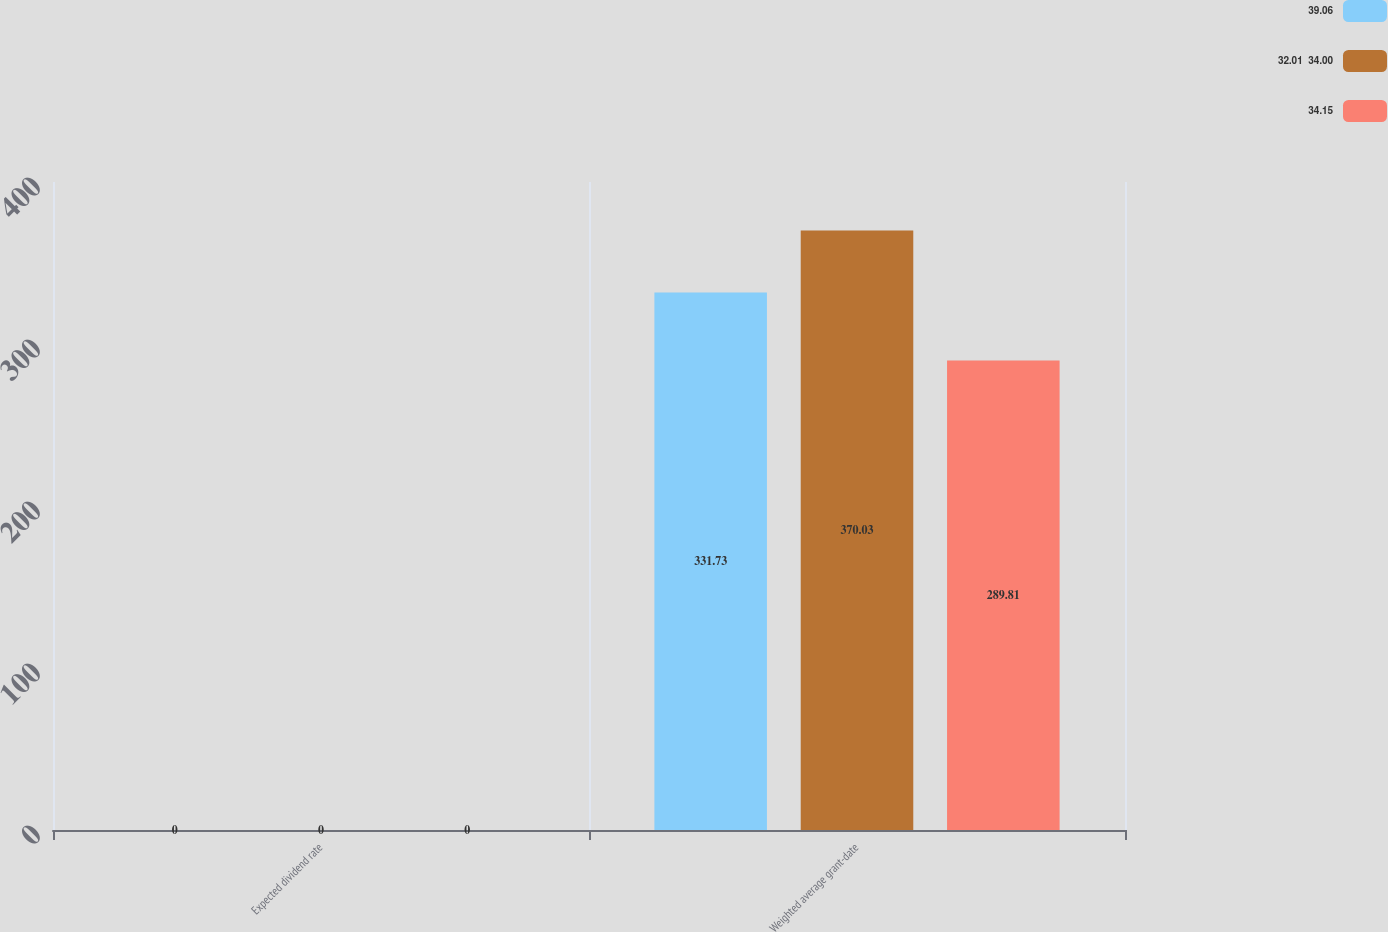Convert chart. <chart><loc_0><loc_0><loc_500><loc_500><stacked_bar_chart><ecel><fcel>Expected dividend rate<fcel>Weighted average grant-date<nl><fcel>39.06<fcel>0<fcel>331.73<nl><fcel>32.01  34.00<fcel>0<fcel>370.03<nl><fcel>34.15<fcel>0<fcel>289.81<nl></chart> 